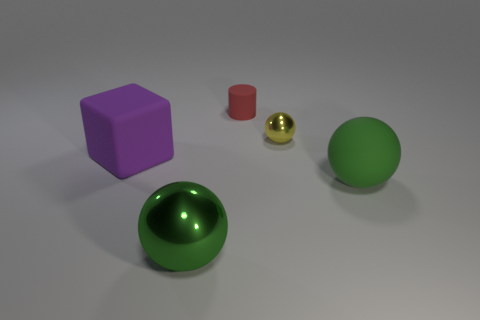Subtract 1 spheres. How many spheres are left? 2 Add 1 large green cylinders. How many objects exist? 6 Subtract all balls. How many objects are left? 2 Add 4 brown spheres. How many brown spheres exist? 4 Subtract 0 blue balls. How many objects are left? 5 Subtract all yellow things. Subtract all yellow balls. How many objects are left? 3 Add 3 small red matte cylinders. How many small red matte cylinders are left? 4 